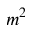<formula> <loc_0><loc_0><loc_500><loc_500>m ^ { 2 }</formula> 